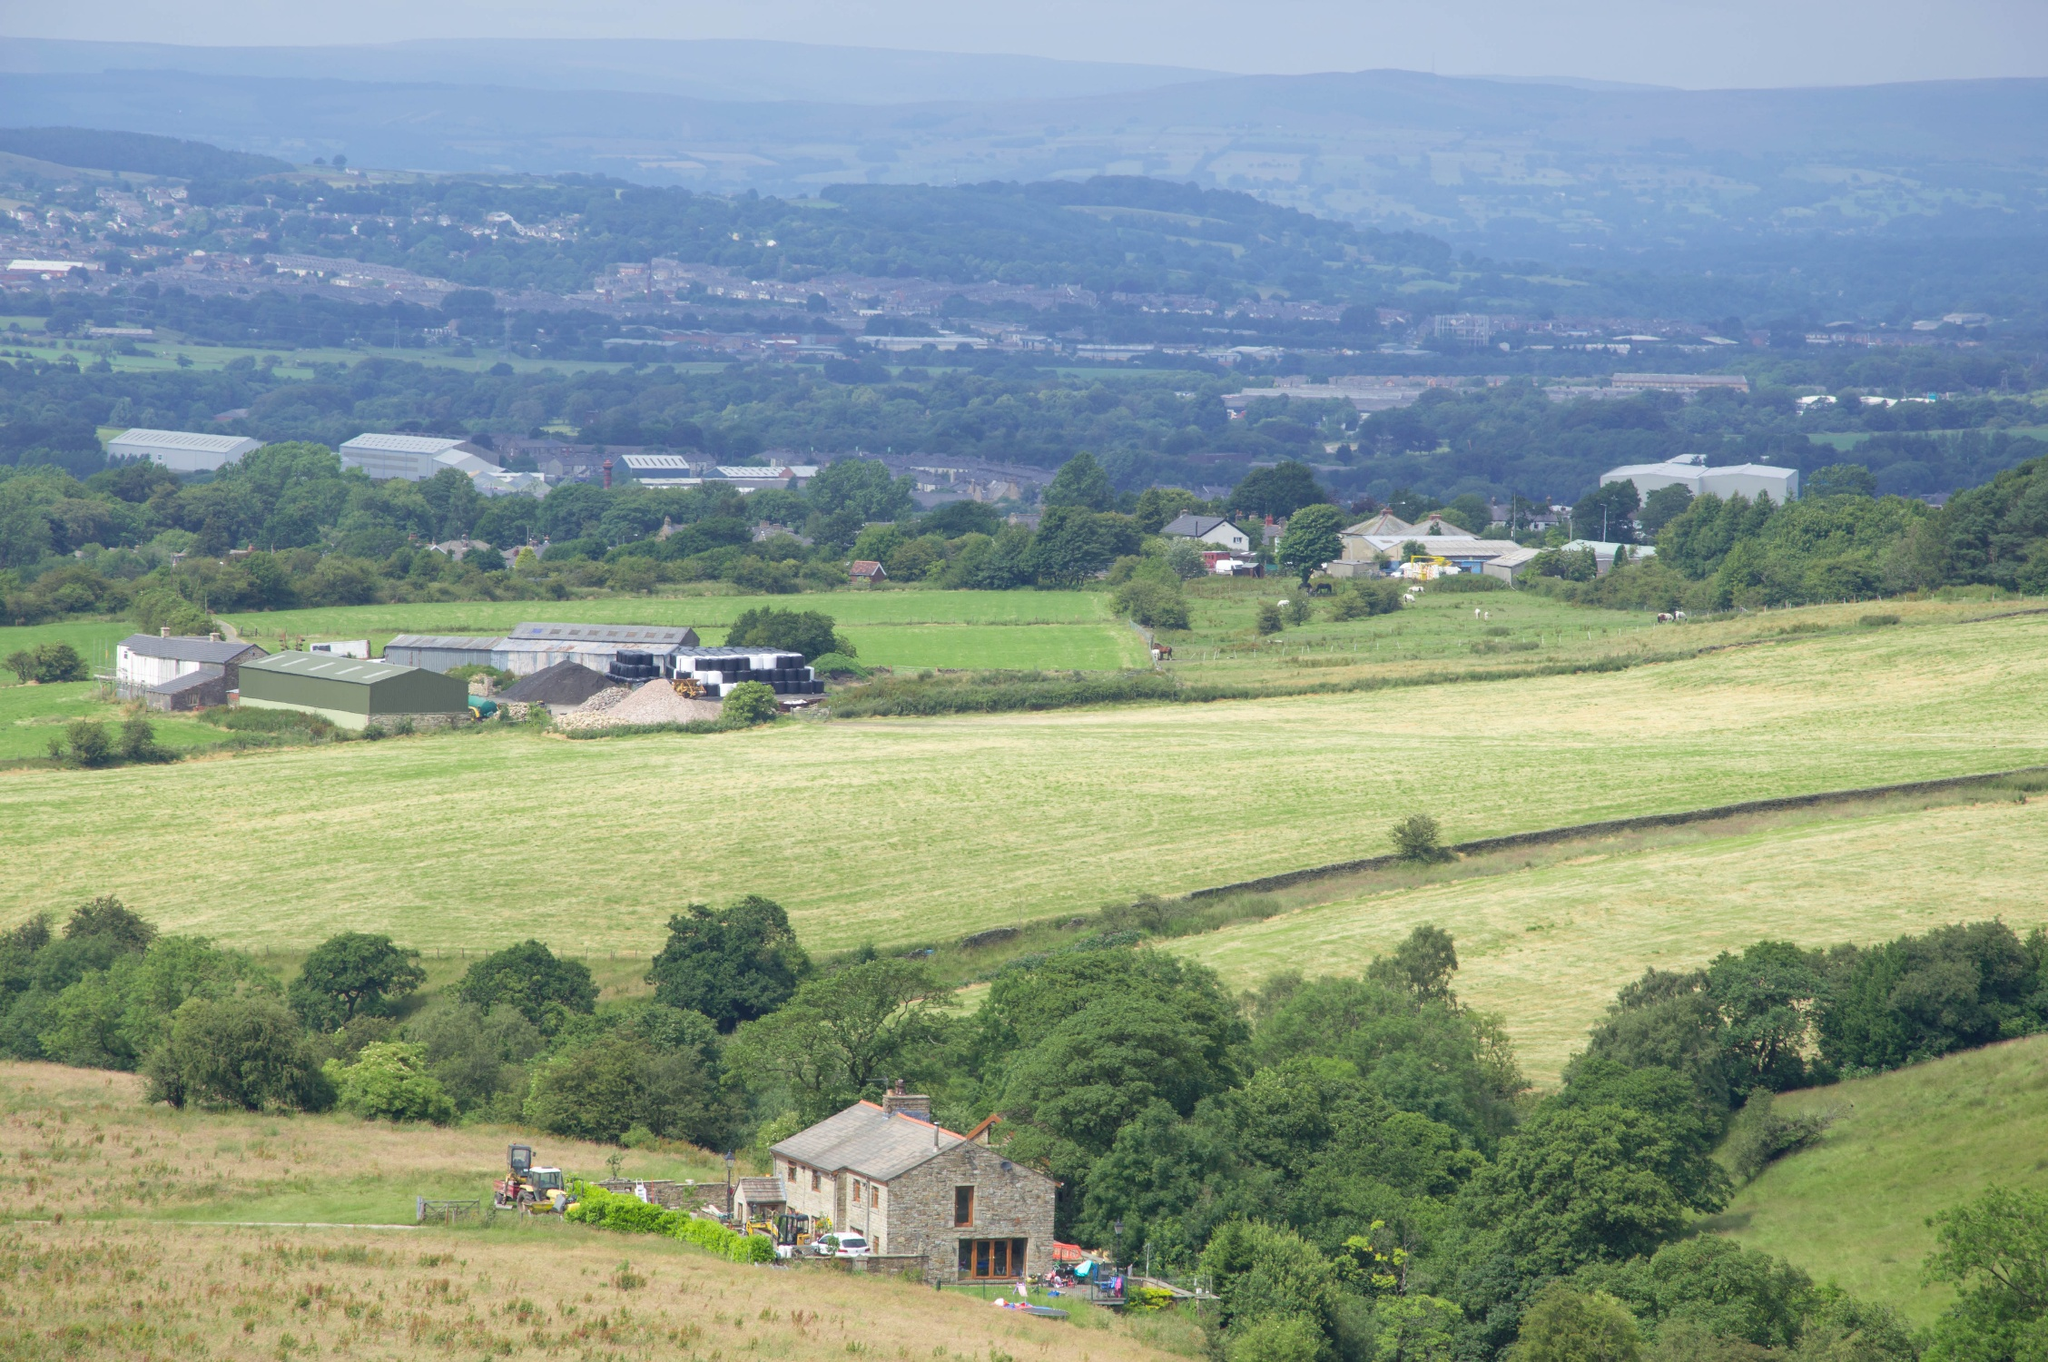What could be the potential impact of climate change on this landscape over the next 50 years? Over the next 50 years, climate change could significantly alter this landscape. Rising temperatures might lead to longer growing seasons but also increased drought stress and heatwaves, challenging water resources essential for agriculture. More intense and unpredictable weather patterns, such as heavy rains or extended dry periods, could disrupt crop cycles and soil health. Additionally, warmer winters might reduce frost periods but could also enable pests and diseases to thrive year-round. The tree lines and hills may no longer provide sufficient protection against the more extreme weather, necessitating shifts in farming practices, crop selection, and livestock management to adapt to these changing conditions. What unique flora and fauna might thrive in this landscape's microclimates? In the varied microclimates of this landscape, you might find a range of unique flora and fauna. The sheltered areas created by the hills and tree lines could support species that prefer more stable and less windy conditions. In wetter or shadier spots, you might find wildflowers like bluebells and primroses, along with animals such as hedgehogs, rabbits, and various bird species like robins and sparrows. In more open and sunnier fields, you could find hardy grasses and crops along with insects like butterflies and bees, which are crucial for pollination. Small mammals like field mice and voles could also thrive here, contributing to a diverse and dynamic ecosystem. 